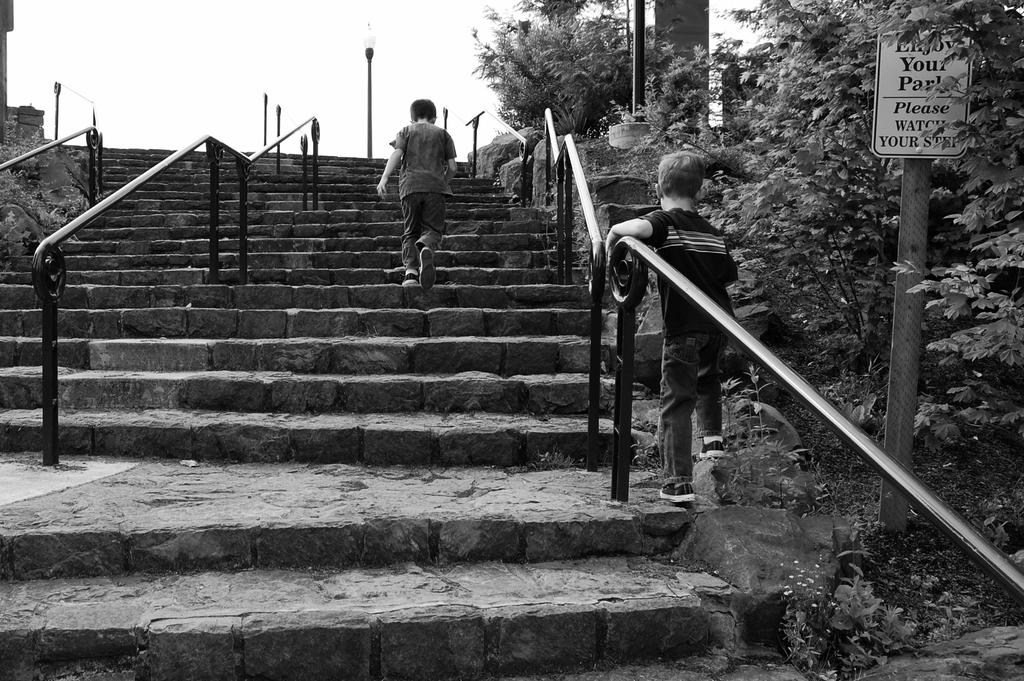What type of structure can be seen in the image? There are stairs in the image. What are the two people in the image doing? Two people are walking in the image. What objects are present in the image that provide support or guidance? There are poles and signboards in the image. What type of natural elements can be seen in the image? There are trees in the image. What type of lighting infrastructure is visible in the image? There are light poles in the image. What is the color scheme of the image? The image is in black and white. What type of skin condition can be seen on the people in the image? There is no indication of any skin condition on the people in the image, as it is in black and white. What type of pan is being used by the people in the image? There is no pan present in the image; it features stairs, poles, signboards, trees, and light poles. 